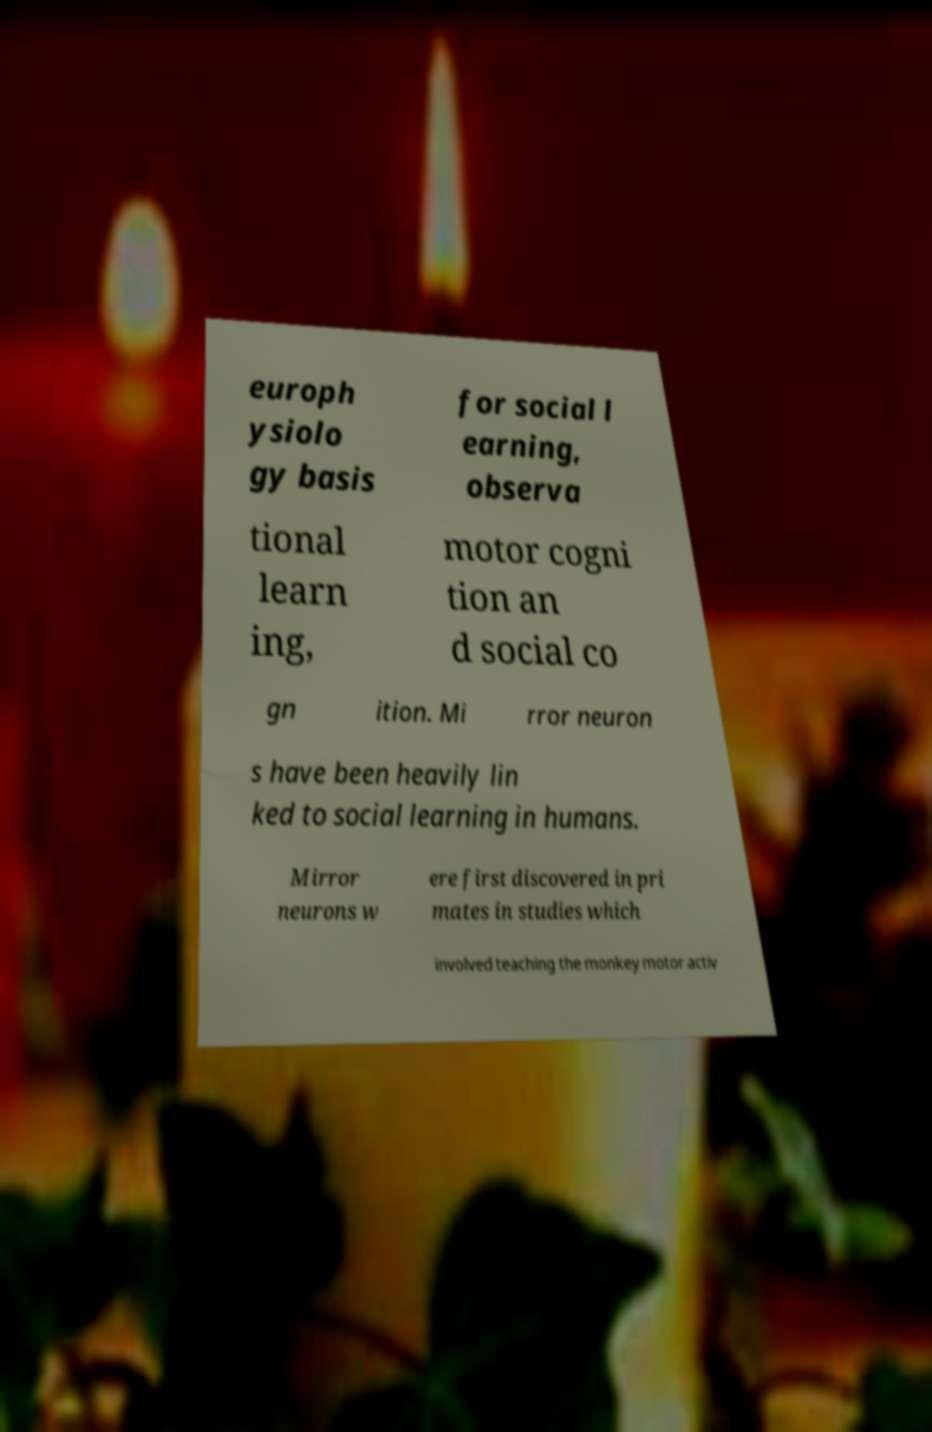For documentation purposes, I need the text within this image transcribed. Could you provide that? europh ysiolo gy basis for social l earning, observa tional learn ing, motor cogni tion an d social co gn ition. Mi rror neuron s have been heavily lin ked to social learning in humans. Mirror neurons w ere first discovered in pri mates in studies which involved teaching the monkey motor activ 